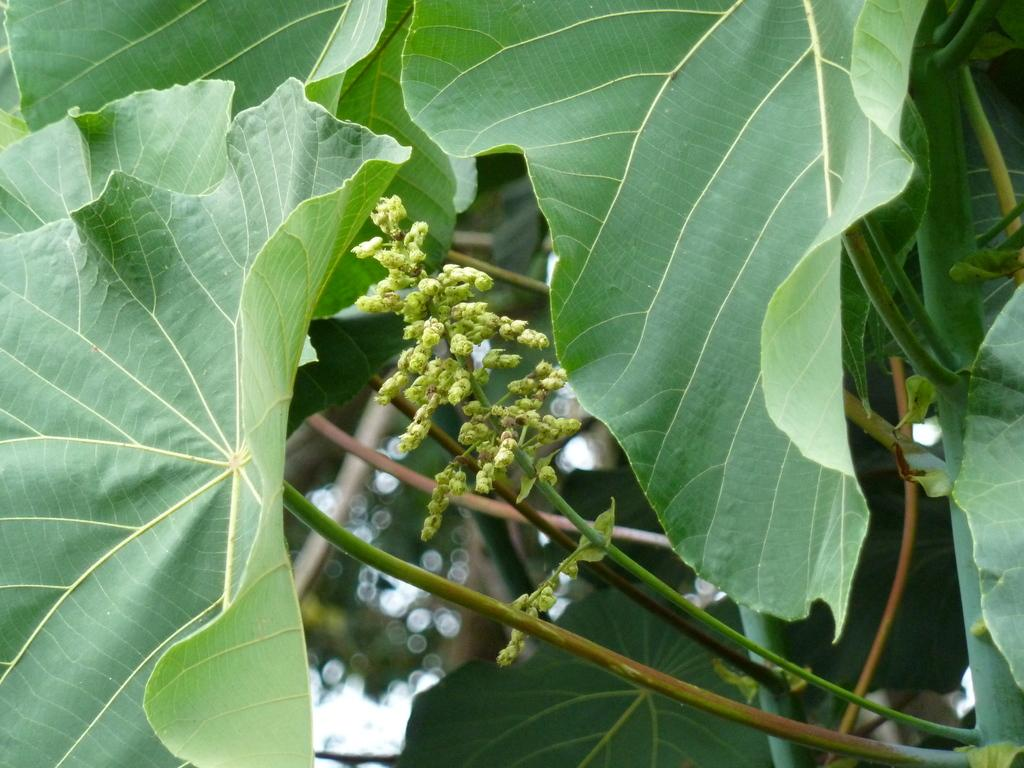What is the main object in the image? There is a tree in the image. Can you describe the background of the image? The background of the image is blurry. What type of truck is visible on top of the tree in the image? There is no truck visible in the image, and the tree does not have a truck on top of it. 